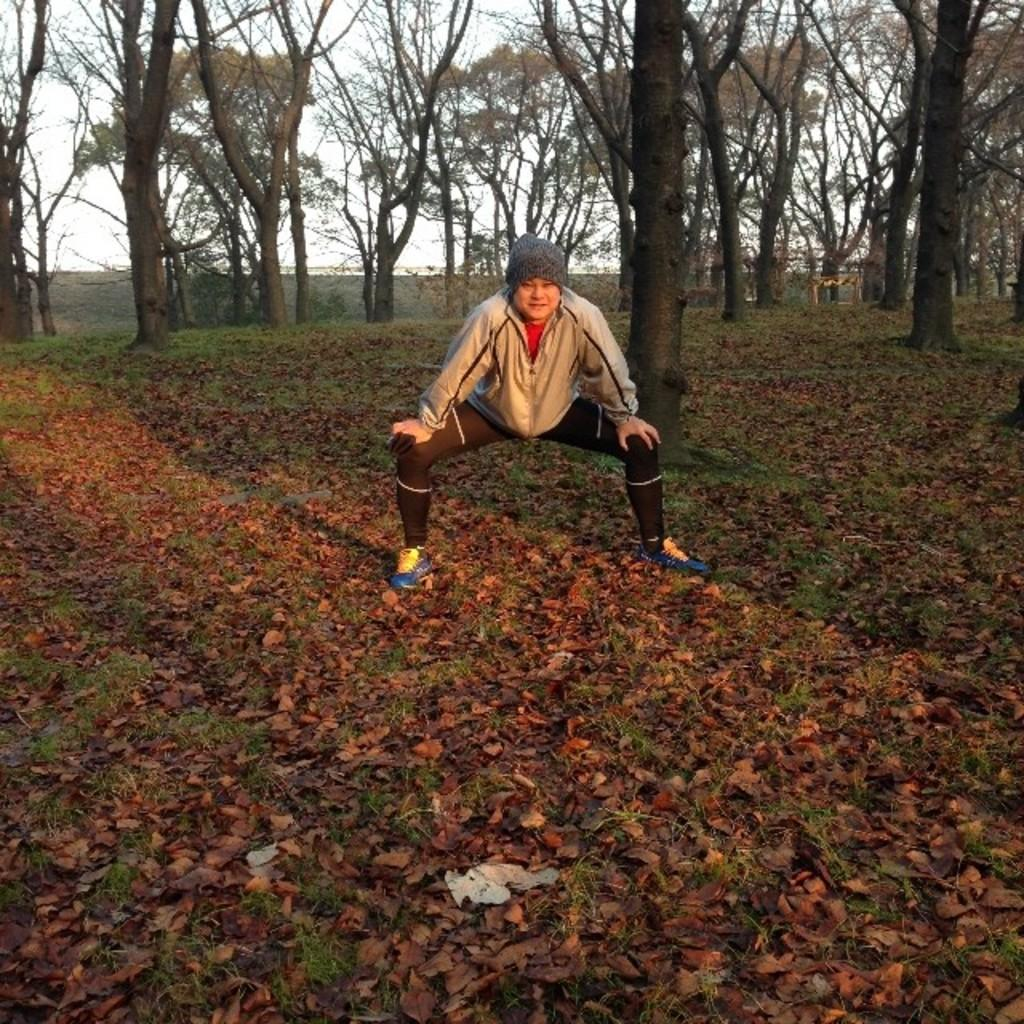What is the main subject of the image? There is a person in the image. What type of clothing is the person wearing? The person is wearing a jacket and a cap. What can be seen on the ground in the image? There is grass and dried leaves on the ground. What is visible in the background of the image? There are trees and the sky in the background. What type of van can be seen in the image? There is no van present in the image. What is the purpose of the person in the image? The image does not provide information about the person's purpose or activity. 